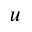<formula> <loc_0><loc_0><loc_500><loc_500>u</formula> 